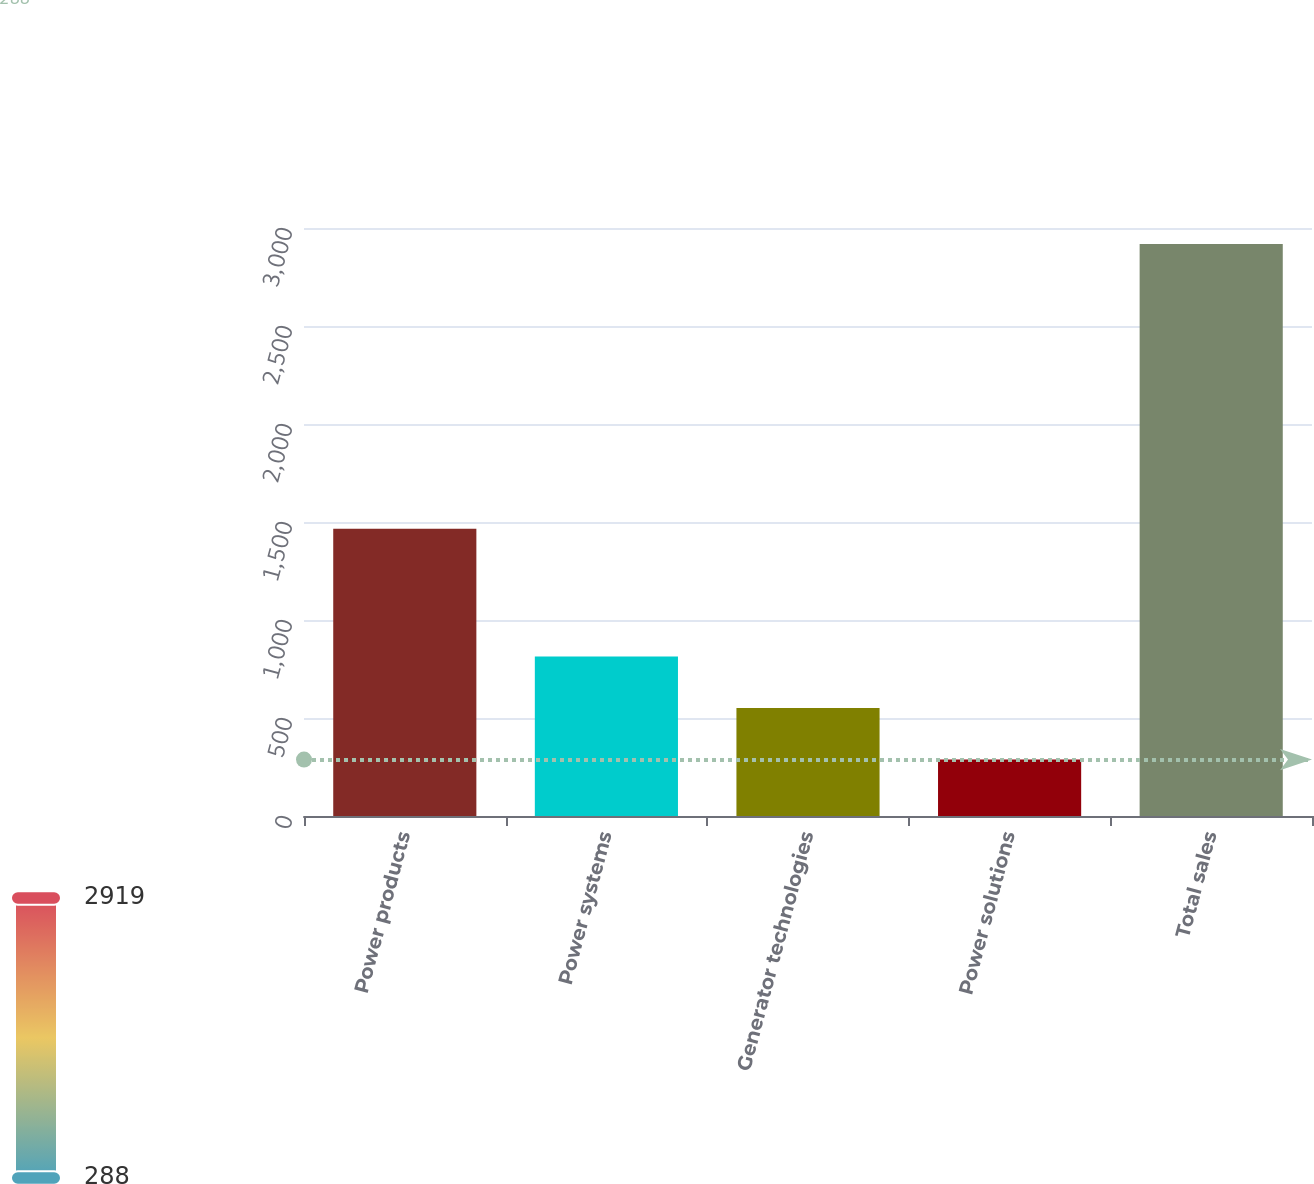Convert chart. <chart><loc_0><loc_0><loc_500><loc_500><bar_chart><fcel>Power products<fcel>Power systems<fcel>Generator technologies<fcel>Power solutions<fcel>Total sales<nl><fcel>1465<fcel>814.2<fcel>551.1<fcel>288<fcel>2919<nl></chart> 